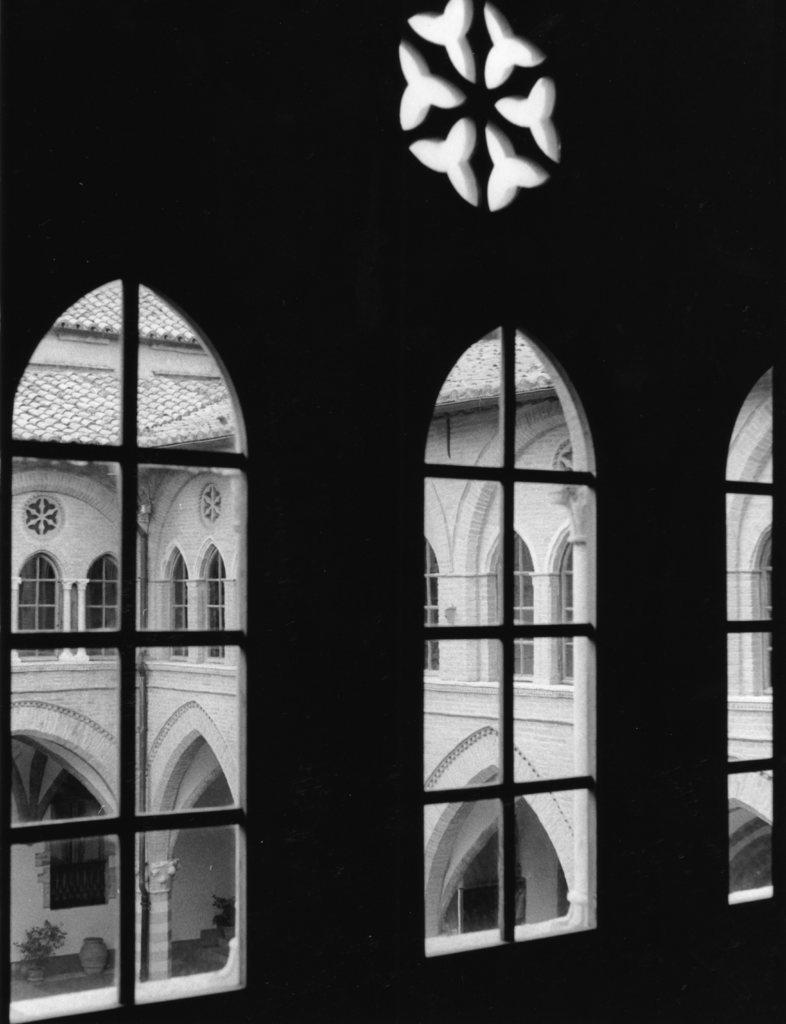What type of material is used for the windows in the image? The windows in the image are made of glass. What can be seen through the glass windows? Windows, pillars, house plants, and roof tops are visible through the glass windows. What type of station can be seen in the aftermath of the error in the image? There is no station or error present in the image; it features glass windows with views of other structures and plants. 